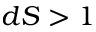<formula> <loc_0><loc_0><loc_500><loc_500>d S > 1</formula> 